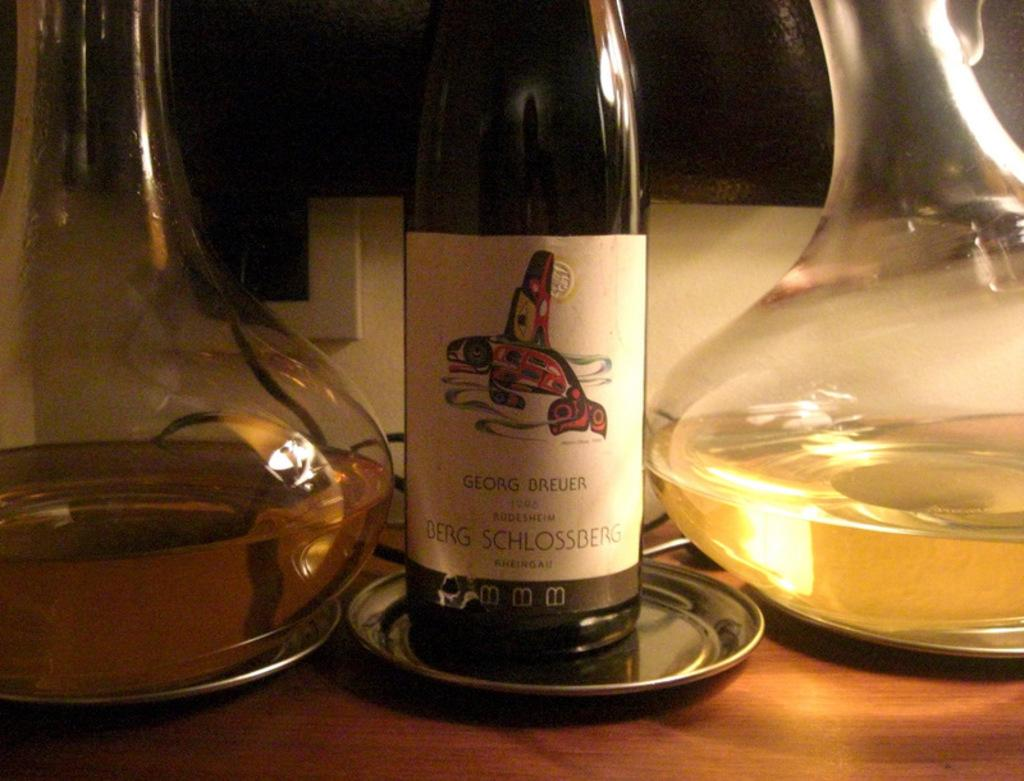<image>
Share a concise interpretation of the image provided. A bottle of wine has a label bearing the name Georg Breuer. 